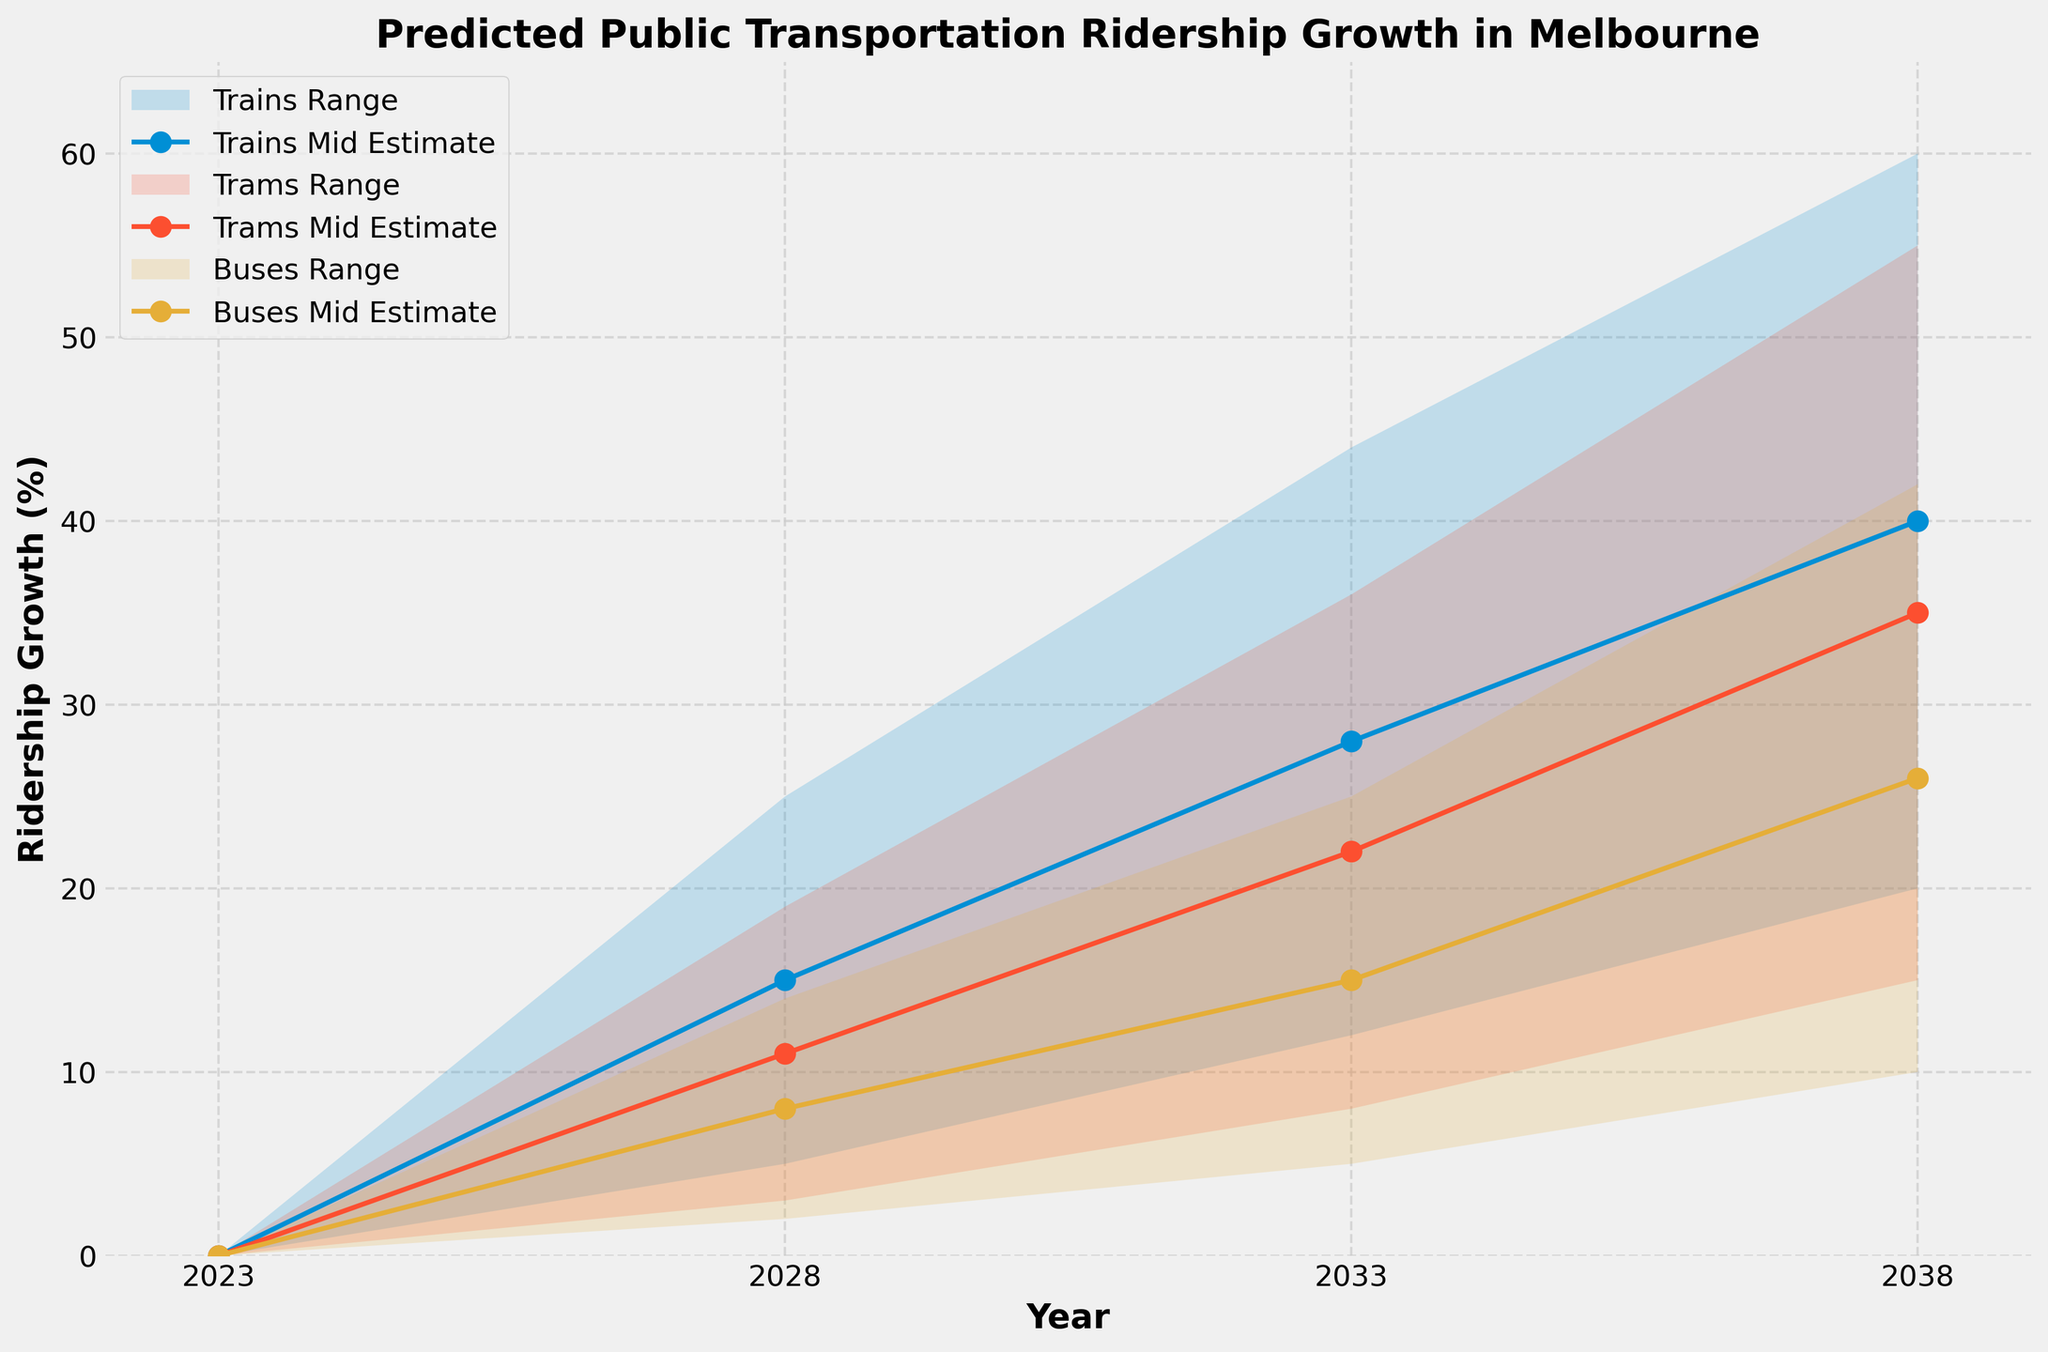What is the title of the figure? The title of the figure is usually found at the top of the chart, which in this case states the main subject of the plot: "Predicted Public Transportation Ridership Growth in Melbourne".
Answer: Predicted Public Transportation Ridership Growth in Melbourne What is the y-axis label of the chart? The y-axis label is placed to indicate the unit of measurement for the data points along the vertical axis, here it should describe what is being measured, which is 'Ridership Growth (%)'.
Answer: Ridership Growth (%) How many transit modes are displayed in the chart? The figure represents different transit modes used in public transportation. By looking at the line plots and legends, we can count the unique labels which should be for trains, trams, and buses.
Answer: 3 Which transit mode is expected to have the highest ridership growth in 2038 according to the mid estimate? To answer this, look at the mid estimate values for the year 2038 and identify the mode with the peak value among trains, trams, and buses.
Answer: Trains What is the mid estimate for trams in the year 2033? Locate the point where the mid estimate line for trams intersects at 2033 on the x-axis to find the y-axis value. This should correspond to one of the data points.
Answer: 22% What is the range of predicted ridership growth for buses in 2028? By checking the range between 'Low Estimate' and 'High Estimate' for buses in 2028, we can find the lower and upper boundaries.
Answer: 2% - 14% Between which years do trains show the largest increase in predicted mid estimate ridership growth? To answer this, we need to compare the changes in the mid estimate points for trains over all intervals (2023-2028, 2028-2033, and 2033-2038). The interval with the maximum increase should be identified.
Answer: 2033 to 2038 How does the predicted range of ridership growth for trams in 2028 compare to that of buses in 2028? Compare the low and high estimates between trams and buses for the year 2028 to determine the differences or similarities.
Answer: Trams: 3% - 19%, Buses: 2% - 14% Which transit mode has the smallest predicted mid estimate ridership growth in 2028? Analyze the mid estimate values for trains, trams, and buses in 2028 and identify which transit mode has the lowest value.
Answer: Buses 